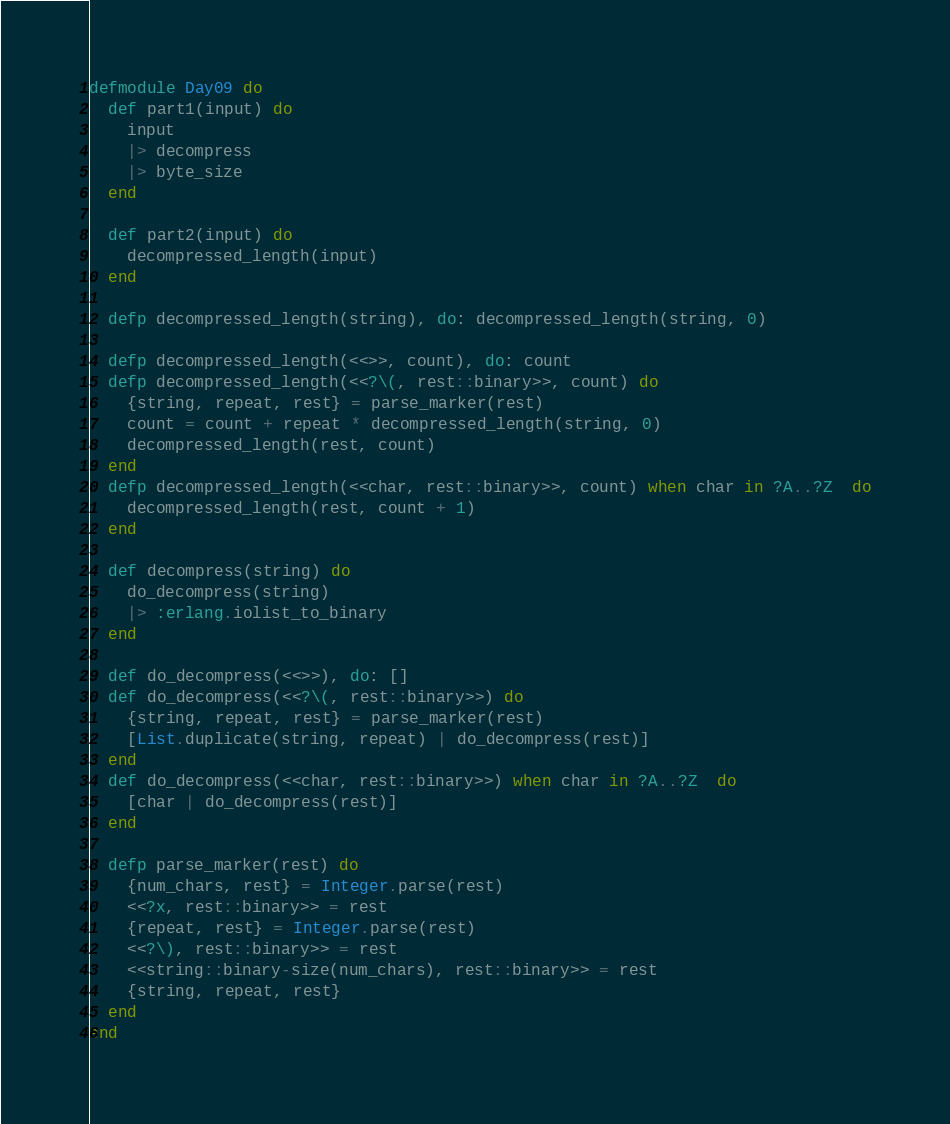<code> <loc_0><loc_0><loc_500><loc_500><_Elixir_>defmodule Day09 do
  def part1(input) do
    input
    |> decompress
    |> byte_size
  end

  def part2(input) do
    decompressed_length(input)
  end

  defp decompressed_length(string), do: decompressed_length(string, 0)

  defp decompressed_length(<<>>, count), do: count
  defp decompressed_length(<<?\(, rest::binary>>, count) do
    {string, repeat, rest} = parse_marker(rest)
    count = count + repeat * decompressed_length(string, 0)
    decompressed_length(rest, count)
  end
  defp decompressed_length(<<char, rest::binary>>, count) when char in ?A..?Z  do
    decompressed_length(rest, count + 1)
  end

  def decompress(string) do
    do_decompress(string)
    |> :erlang.iolist_to_binary
  end

  def do_decompress(<<>>), do: []
  def do_decompress(<<?\(, rest::binary>>) do
    {string, repeat, rest} = parse_marker(rest)
    [List.duplicate(string, repeat) | do_decompress(rest)]
  end
  def do_decompress(<<char, rest::binary>>) when char in ?A..?Z  do
    [char | do_decompress(rest)]
  end

  defp parse_marker(rest) do
    {num_chars, rest} = Integer.parse(rest)
    <<?x, rest::binary>> = rest
    {repeat, rest} = Integer.parse(rest)
    <<?\), rest::binary>> = rest
    <<string::binary-size(num_chars), rest::binary>> = rest
    {string, repeat, rest}
  end
end
</code> 